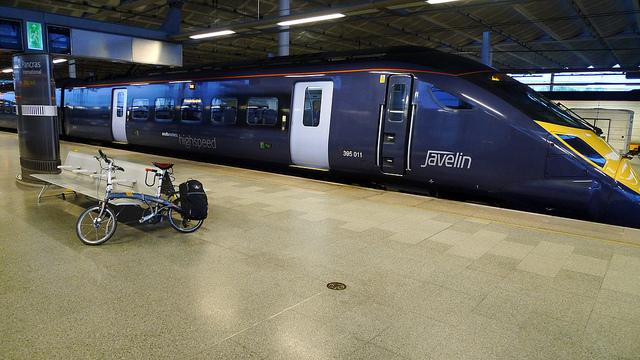How can one tell where the doors are on the train? Please explain your reasoning. white color. They are different colors than the rest of the train 